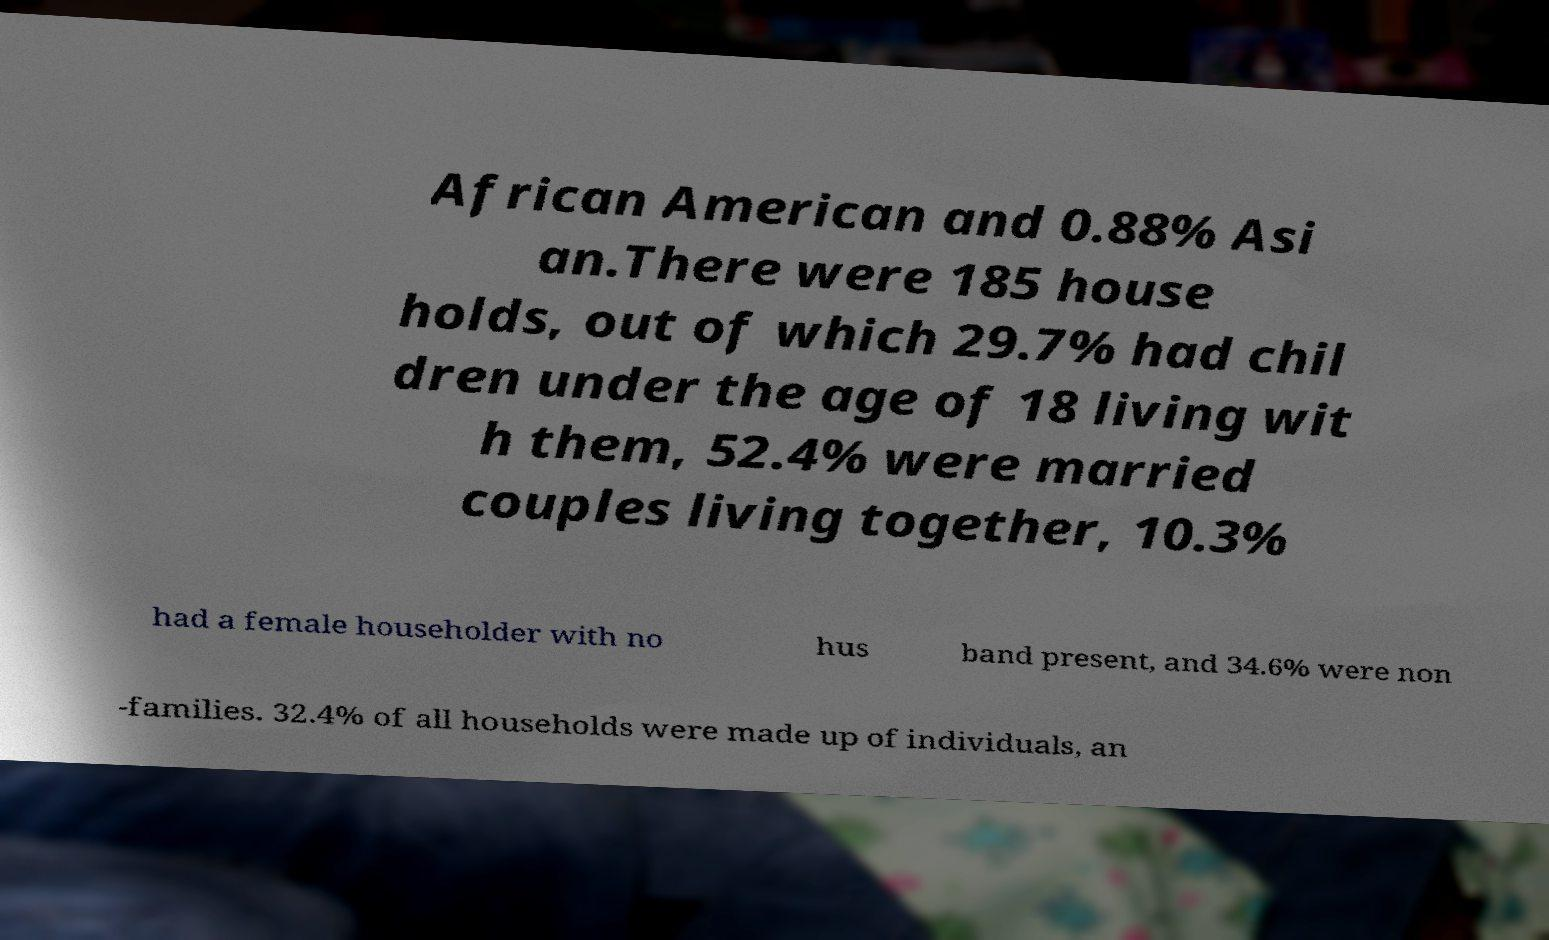There's text embedded in this image that I need extracted. Can you transcribe it verbatim? African American and 0.88% Asi an.There were 185 house holds, out of which 29.7% had chil dren under the age of 18 living wit h them, 52.4% were married couples living together, 10.3% had a female householder with no hus band present, and 34.6% were non -families. 32.4% of all households were made up of individuals, an 